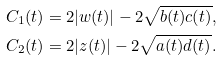<formula> <loc_0><loc_0><loc_500><loc_500>C _ { 1 } ( t ) & = 2 | w ( t ) | - 2 \sqrt { b ( t ) c ( t ) } , \\ C _ { 2 } ( t ) & = 2 | z ( t ) | - 2 \sqrt { a ( t ) d ( t ) } .</formula> 